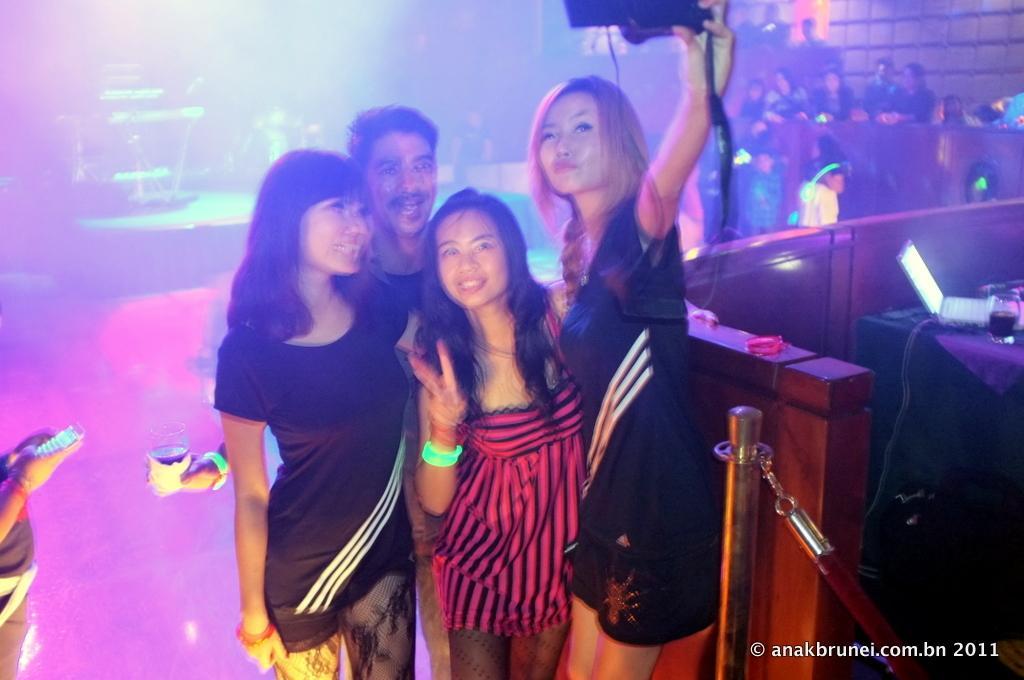Please provide a concise description of this image. In this image I can see three women and a man are standing and I can see a woman is holding a camera in her hand. I can see a pole and a table with laptop and glass on it. In the background I can see few persons, the wall and few other objects. 